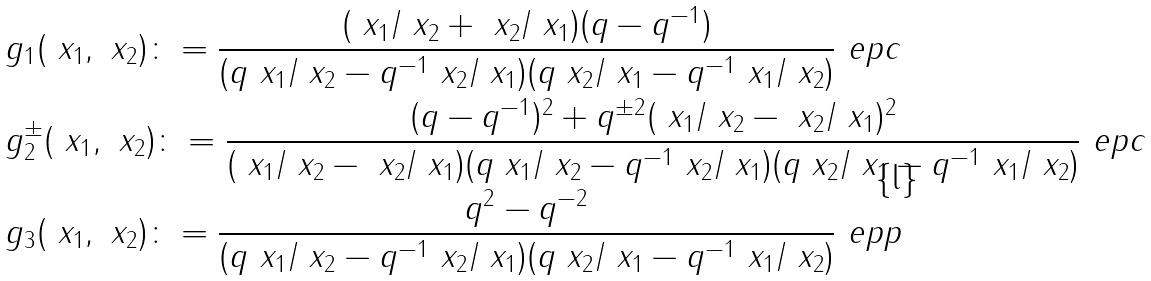Convert formula to latex. <formula><loc_0><loc_0><loc_500><loc_500>& g _ { 1 } ( \ x _ { 1 } , \ x _ { 2 } ) \colon = \frac { ( \ x _ { 1 } / \ x _ { 2 } + \ x _ { 2 } / \ x _ { 1 } ) ( q - q ^ { - 1 } ) } { ( q \ x _ { 1 } / \ x _ { 2 } - q ^ { - 1 } \ x _ { 2 } / \ x _ { 1 } ) ( q \ x _ { 2 } / \ x _ { 1 } - q ^ { - 1 } \ x _ { 1 } / \ x _ { 2 } ) } \ e p c \\ & g _ { 2 } ^ { \pm } ( \ x _ { 1 } , \ x _ { 2 } ) \colon = \frac { ( q - q ^ { - 1 } ) ^ { 2 } + q ^ { \pm 2 } ( \ x _ { 1 } / \ x _ { 2 } - \ x _ { 2 } / \ x _ { 1 } ) ^ { 2 } } { ( \ x _ { 1 } / \ x _ { 2 } - \ x _ { 2 } / \ x _ { 1 } ) ( q \ x _ { 1 } / \ x _ { 2 } - q ^ { - 1 } \ x _ { 2 } / \ x _ { 1 } ) ( q \ x _ { 2 } / \ x _ { 1 } - q ^ { - 1 } \ x _ { 1 } / \ x _ { 2 } ) } \ e p c \\ & g _ { 3 } ( \ x _ { 1 } , \ x _ { 2 } ) \colon = \frac { q ^ { 2 } - q ^ { - 2 } } { ( q \ x _ { 1 } / \ x _ { 2 } - q ^ { - 1 } \ x _ { 2 } / \ x _ { 1 } ) ( q \ x _ { 2 } / \ x _ { 1 } - q ^ { - 1 } \ x _ { 1 } / \ x _ { 2 } ) } \ e p p</formula> 